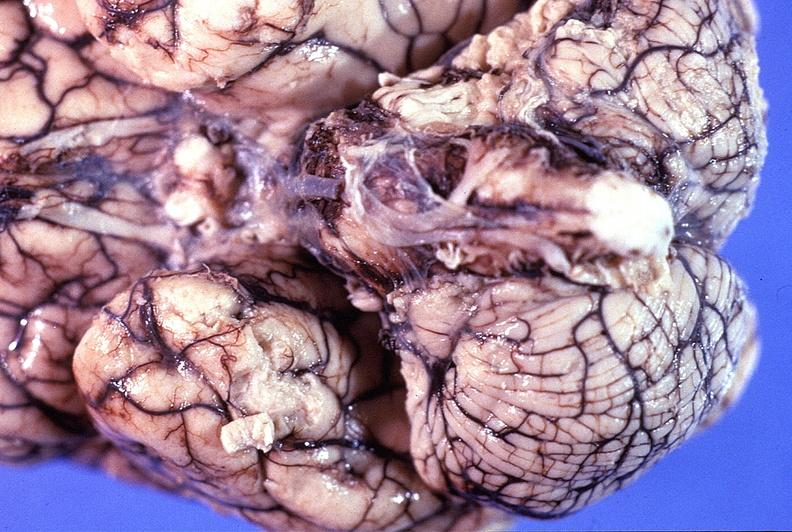s heel ulcer present?
Answer the question using a single word or phrase. No 